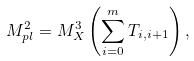Convert formula to latex. <formula><loc_0><loc_0><loc_500><loc_500>M _ { p l } ^ { 2 } = M _ { X } ^ { 3 } \left ( \sum _ { i = 0 } ^ { m } T _ { i , i + 1 } \right ) , \,</formula> 